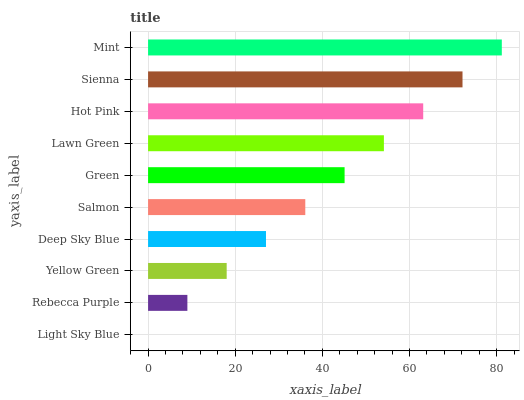Is Light Sky Blue the minimum?
Answer yes or no. Yes. Is Mint the maximum?
Answer yes or no. Yes. Is Rebecca Purple the minimum?
Answer yes or no. No. Is Rebecca Purple the maximum?
Answer yes or no. No. Is Rebecca Purple greater than Light Sky Blue?
Answer yes or no. Yes. Is Light Sky Blue less than Rebecca Purple?
Answer yes or no. Yes. Is Light Sky Blue greater than Rebecca Purple?
Answer yes or no. No. Is Rebecca Purple less than Light Sky Blue?
Answer yes or no. No. Is Green the high median?
Answer yes or no. Yes. Is Salmon the low median?
Answer yes or no. Yes. Is Lawn Green the high median?
Answer yes or no. No. Is Sienna the low median?
Answer yes or no. No. 